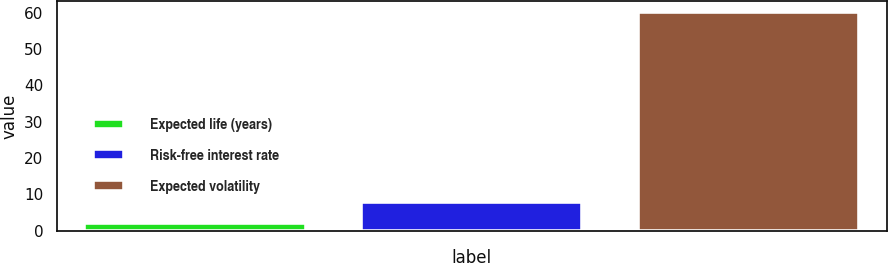Convert chart. <chart><loc_0><loc_0><loc_500><loc_500><bar_chart><fcel>Expected life (years)<fcel>Risk-free interest rate<fcel>Expected volatility<nl><fcel>2.1<fcel>7.9<fcel>60.1<nl></chart> 